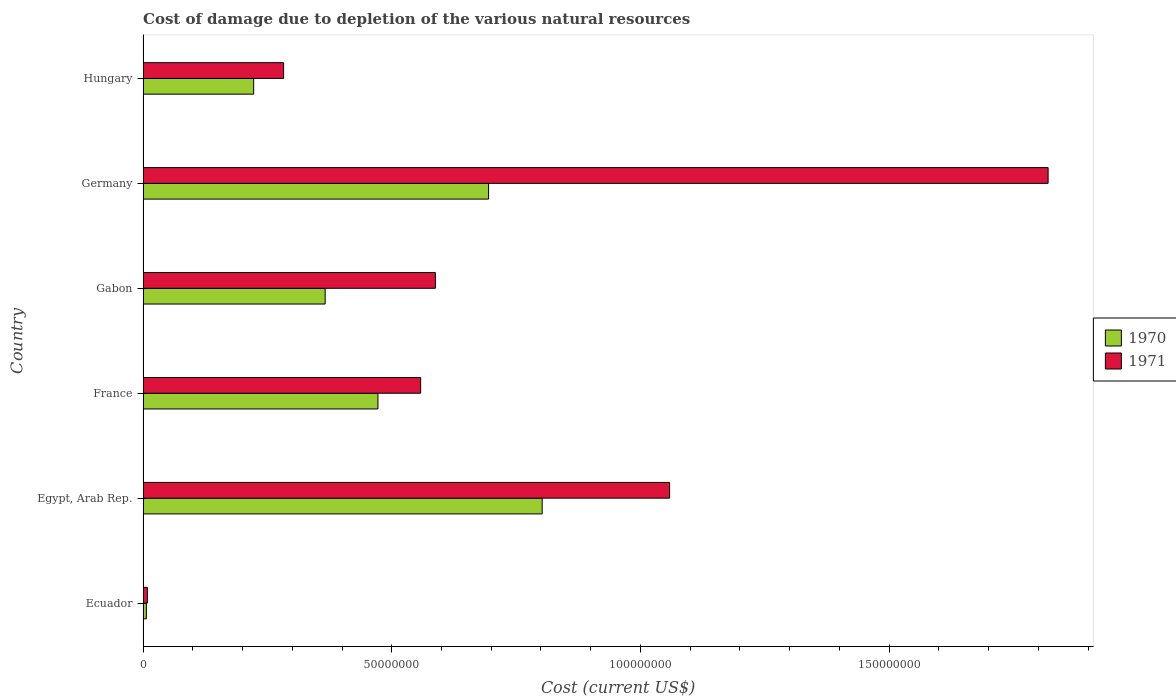How many different coloured bars are there?
Your response must be concise. 2. Are the number of bars per tick equal to the number of legend labels?
Your answer should be compact. Yes. Are the number of bars on each tick of the Y-axis equal?
Make the answer very short. Yes. What is the label of the 3rd group of bars from the top?
Make the answer very short. Gabon. What is the cost of damage caused due to the depletion of various natural resources in 1971 in Ecuador?
Offer a terse response. 8.71e+05. Across all countries, what is the maximum cost of damage caused due to the depletion of various natural resources in 1971?
Offer a very short reply. 1.82e+08. Across all countries, what is the minimum cost of damage caused due to the depletion of various natural resources in 1970?
Give a very brief answer. 6.65e+05. In which country was the cost of damage caused due to the depletion of various natural resources in 1970 maximum?
Ensure brevity in your answer.  Egypt, Arab Rep. In which country was the cost of damage caused due to the depletion of various natural resources in 1971 minimum?
Ensure brevity in your answer.  Ecuador. What is the total cost of damage caused due to the depletion of various natural resources in 1970 in the graph?
Keep it short and to the point. 2.56e+08. What is the difference between the cost of damage caused due to the depletion of various natural resources in 1971 in Gabon and that in Germany?
Ensure brevity in your answer.  -1.23e+08. What is the difference between the cost of damage caused due to the depletion of various natural resources in 1970 in Germany and the cost of damage caused due to the depletion of various natural resources in 1971 in France?
Provide a succinct answer. 1.37e+07. What is the average cost of damage caused due to the depletion of various natural resources in 1971 per country?
Provide a short and direct response. 7.19e+07. What is the difference between the cost of damage caused due to the depletion of various natural resources in 1971 and cost of damage caused due to the depletion of various natural resources in 1970 in Hungary?
Provide a short and direct response. 6.02e+06. In how many countries, is the cost of damage caused due to the depletion of various natural resources in 1970 greater than 180000000 US$?
Your answer should be very brief. 0. What is the ratio of the cost of damage caused due to the depletion of various natural resources in 1970 in France to that in Gabon?
Keep it short and to the point. 1.29. Is the cost of damage caused due to the depletion of various natural resources in 1971 in Egypt, Arab Rep. less than that in Gabon?
Ensure brevity in your answer.  No. Is the difference between the cost of damage caused due to the depletion of various natural resources in 1971 in France and Gabon greater than the difference between the cost of damage caused due to the depletion of various natural resources in 1970 in France and Gabon?
Provide a succinct answer. No. What is the difference between the highest and the second highest cost of damage caused due to the depletion of various natural resources in 1970?
Offer a terse response. 1.08e+07. What is the difference between the highest and the lowest cost of damage caused due to the depletion of various natural resources in 1971?
Give a very brief answer. 1.81e+08. Is the sum of the cost of damage caused due to the depletion of various natural resources in 1970 in Gabon and Germany greater than the maximum cost of damage caused due to the depletion of various natural resources in 1971 across all countries?
Offer a very short reply. No. What does the 2nd bar from the top in Ecuador represents?
Give a very brief answer. 1970. What does the 2nd bar from the bottom in Hungary represents?
Keep it short and to the point. 1971. Are all the bars in the graph horizontal?
Keep it short and to the point. Yes. How many countries are there in the graph?
Ensure brevity in your answer.  6. How are the legend labels stacked?
Make the answer very short. Vertical. What is the title of the graph?
Offer a terse response. Cost of damage due to depletion of the various natural resources. Does "1994" appear as one of the legend labels in the graph?
Your answer should be very brief. No. What is the label or title of the X-axis?
Provide a succinct answer. Cost (current US$). What is the label or title of the Y-axis?
Offer a very short reply. Country. What is the Cost (current US$) of 1970 in Ecuador?
Provide a succinct answer. 6.65e+05. What is the Cost (current US$) of 1971 in Ecuador?
Give a very brief answer. 8.71e+05. What is the Cost (current US$) of 1970 in Egypt, Arab Rep.?
Offer a very short reply. 8.02e+07. What is the Cost (current US$) in 1971 in Egypt, Arab Rep.?
Give a very brief answer. 1.06e+08. What is the Cost (current US$) in 1970 in France?
Give a very brief answer. 4.72e+07. What is the Cost (current US$) of 1971 in France?
Give a very brief answer. 5.58e+07. What is the Cost (current US$) in 1970 in Gabon?
Offer a very short reply. 3.66e+07. What is the Cost (current US$) of 1971 in Gabon?
Provide a succinct answer. 5.88e+07. What is the Cost (current US$) of 1970 in Germany?
Your answer should be very brief. 6.95e+07. What is the Cost (current US$) of 1971 in Germany?
Make the answer very short. 1.82e+08. What is the Cost (current US$) in 1970 in Hungary?
Your response must be concise. 2.22e+07. What is the Cost (current US$) of 1971 in Hungary?
Your response must be concise. 2.83e+07. Across all countries, what is the maximum Cost (current US$) of 1970?
Keep it short and to the point. 8.02e+07. Across all countries, what is the maximum Cost (current US$) in 1971?
Offer a terse response. 1.82e+08. Across all countries, what is the minimum Cost (current US$) of 1970?
Your answer should be very brief. 6.65e+05. Across all countries, what is the minimum Cost (current US$) of 1971?
Offer a very short reply. 8.71e+05. What is the total Cost (current US$) of 1970 in the graph?
Keep it short and to the point. 2.56e+08. What is the total Cost (current US$) of 1971 in the graph?
Provide a short and direct response. 4.32e+08. What is the difference between the Cost (current US$) of 1970 in Ecuador and that in Egypt, Arab Rep.?
Your answer should be very brief. -7.96e+07. What is the difference between the Cost (current US$) in 1971 in Ecuador and that in Egypt, Arab Rep.?
Your answer should be very brief. -1.05e+08. What is the difference between the Cost (current US$) in 1970 in Ecuador and that in France?
Make the answer very short. -4.66e+07. What is the difference between the Cost (current US$) in 1971 in Ecuador and that in France?
Offer a very short reply. -5.49e+07. What is the difference between the Cost (current US$) in 1970 in Ecuador and that in Gabon?
Provide a short and direct response. -3.59e+07. What is the difference between the Cost (current US$) of 1971 in Ecuador and that in Gabon?
Provide a succinct answer. -5.79e+07. What is the difference between the Cost (current US$) of 1970 in Ecuador and that in Germany?
Give a very brief answer. -6.88e+07. What is the difference between the Cost (current US$) in 1971 in Ecuador and that in Germany?
Keep it short and to the point. -1.81e+08. What is the difference between the Cost (current US$) of 1970 in Ecuador and that in Hungary?
Your response must be concise. -2.16e+07. What is the difference between the Cost (current US$) of 1971 in Ecuador and that in Hungary?
Give a very brief answer. -2.74e+07. What is the difference between the Cost (current US$) of 1970 in Egypt, Arab Rep. and that in France?
Ensure brevity in your answer.  3.30e+07. What is the difference between the Cost (current US$) in 1971 in Egypt, Arab Rep. and that in France?
Provide a short and direct response. 5.01e+07. What is the difference between the Cost (current US$) in 1970 in Egypt, Arab Rep. and that in Gabon?
Offer a terse response. 4.36e+07. What is the difference between the Cost (current US$) in 1971 in Egypt, Arab Rep. and that in Gabon?
Your response must be concise. 4.71e+07. What is the difference between the Cost (current US$) in 1970 in Egypt, Arab Rep. and that in Germany?
Your answer should be compact. 1.08e+07. What is the difference between the Cost (current US$) of 1971 in Egypt, Arab Rep. and that in Germany?
Offer a very short reply. -7.61e+07. What is the difference between the Cost (current US$) of 1970 in Egypt, Arab Rep. and that in Hungary?
Keep it short and to the point. 5.80e+07. What is the difference between the Cost (current US$) in 1971 in Egypt, Arab Rep. and that in Hungary?
Your answer should be compact. 7.76e+07. What is the difference between the Cost (current US$) in 1970 in France and that in Gabon?
Offer a terse response. 1.06e+07. What is the difference between the Cost (current US$) of 1971 in France and that in Gabon?
Offer a terse response. -2.96e+06. What is the difference between the Cost (current US$) of 1970 in France and that in Germany?
Your response must be concise. -2.22e+07. What is the difference between the Cost (current US$) in 1971 in France and that in Germany?
Your answer should be very brief. -1.26e+08. What is the difference between the Cost (current US$) in 1970 in France and that in Hungary?
Make the answer very short. 2.50e+07. What is the difference between the Cost (current US$) of 1971 in France and that in Hungary?
Provide a short and direct response. 2.76e+07. What is the difference between the Cost (current US$) in 1970 in Gabon and that in Germany?
Your answer should be very brief. -3.29e+07. What is the difference between the Cost (current US$) of 1971 in Gabon and that in Germany?
Make the answer very short. -1.23e+08. What is the difference between the Cost (current US$) in 1970 in Gabon and that in Hungary?
Provide a succinct answer. 1.44e+07. What is the difference between the Cost (current US$) of 1971 in Gabon and that in Hungary?
Offer a terse response. 3.05e+07. What is the difference between the Cost (current US$) of 1970 in Germany and that in Hungary?
Keep it short and to the point. 4.72e+07. What is the difference between the Cost (current US$) of 1971 in Germany and that in Hungary?
Keep it short and to the point. 1.54e+08. What is the difference between the Cost (current US$) in 1970 in Ecuador and the Cost (current US$) in 1971 in Egypt, Arab Rep.?
Your response must be concise. -1.05e+08. What is the difference between the Cost (current US$) of 1970 in Ecuador and the Cost (current US$) of 1971 in France?
Offer a terse response. -5.52e+07. What is the difference between the Cost (current US$) in 1970 in Ecuador and the Cost (current US$) in 1971 in Gabon?
Offer a very short reply. -5.81e+07. What is the difference between the Cost (current US$) of 1970 in Ecuador and the Cost (current US$) of 1971 in Germany?
Provide a short and direct response. -1.81e+08. What is the difference between the Cost (current US$) of 1970 in Ecuador and the Cost (current US$) of 1971 in Hungary?
Ensure brevity in your answer.  -2.76e+07. What is the difference between the Cost (current US$) of 1970 in Egypt, Arab Rep. and the Cost (current US$) of 1971 in France?
Keep it short and to the point. 2.44e+07. What is the difference between the Cost (current US$) of 1970 in Egypt, Arab Rep. and the Cost (current US$) of 1971 in Gabon?
Keep it short and to the point. 2.15e+07. What is the difference between the Cost (current US$) of 1970 in Egypt, Arab Rep. and the Cost (current US$) of 1971 in Germany?
Offer a terse response. -1.02e+08. What is the difference between the Cost (current US$) of 1970 in Egypt, Arab Rep. and the Cost (current US$) of 1971 in Hungary?
Provide a short and direct response. 5.20e+07. What is the difference between the Cost (current US$) of 1970 in France and the Cost (current US$) of 1971 in Gabon?
Give a very brief answer. -1.15e+07. What is the difference between the Cost (current US$) in 1970 in France and the Cost (current US$) in 1971 in Germany?
Provide a succinct answer. -1.35e+08. What is the difference between the Cost (current US$) in 1970 in France and the Cost (current US$) in 1971 in Hungary?
Your answer should be very brief. 1.90e+07. What is the difference between the Cost (current US$) of 1970 in Gabon and the Cost (current US$) of 1971 in Germany?
Your response must be concise. -1.45e+08. What is the difference between the Cost (current US$) of 1970 in Gabon and the Cost (current US$) of 1971 in Hungary?
Your response must be concise. 8.35e+06. What is the difference between the Cost (current US$) of 1970 in Germany and the Cost (current US$) of 1971 in Hungary?
Offer a terse response. 4.12e+07. What is the average Cost (current US$) in 1970 per country?
Offer a very short reply. 4.27e+07. What is the average Cost (current US$) in 1971 per country?
Your response must be concise. 7.19e+07. What is the difference between the Cost (current US$) in 1970 and Cost (current US$) in 1971 in Ecuador?
Ensure brevity in your answer.  -2.07e+05. What is the difference between the Cost (current US$) in 1970 and Cost (current US$) in 1971 in Egypt, Arab Rep.?
Your answer should be compact. -2.56e+07. What is the difference between the Cost (current US$) of 1970 and Cost (current US$) of 1971 in France?
Your answer should be very brief. -8.59e+06. What is the difference between the Cost (current US$) in 1970 and Cost (current US$) in 1971 in Gabon?
Keep it short and to the point. -2.22e+07. What is the difference between the Cost (current US$) in 1970 and Cost (current US$) in 1971 in Germany?
Your response must be concise. -1.13e+08. What is the difference between the Cost (current US$) of 1970 and Cost (current US$) of 1971 in Hungary?
Your answer should be very brief. -6.02e+06. What is the ratio of the Cost (current US$) in 1970 in Ecuador to that in Egypt, Arab Rep.?
Provide a succinct answer. 0.01. What is the ratio of the Cost (current US$) of 1971 in Ecuador to that in Egypt, Arab Rep.?
Offer a very short reply. 0.01. What is the ratio of the Cost (current US$) of 1970 in Ecuador to that in France?
Ensure brevity in your answer.  0.01. What is the ratio of the Cost (current US$) of 1971 in Ecuador to that in France?
Keep it short and to the point. 0.02. What is the ratio of the Cost (current US$) in 1970 in Ecuador to that in Gabon?
Keep it short and to the point. 0.02. What is the ratio of the Cost (current US$) in 1971 in Ecuador to that in Gabon?
Your response must be concise. 0.01. What is the ratio of the Cost (current US$) of 1970 in Ecuador to that in Germany?
Give a very brief answer. 0.01. What is the ratio of the Cost (current US$) of 1971 in Ecuador to that in Germany?
Ensure brevity in your answer.  0. What is the ratio of the Cost (current US$) in 1970 in Ecuador to that in Hungary?
Provide a succinct answer. 0.03. What is the ratio of the Cost (current US$) of 1971 in Ecuador to that in Hungary?
Your answer should be compact. 0.03. What is the ratio of the Cost (current US$) of 1970 in Egypt, Arab Rep. to that in France?
Your answer should be very brief. 1.7. What is the ratio of the Cost (current US$) of 1971 in Egypt, Arab Rep. to that in France?
Your response must be concise. 1.9. What is the ratio of the Cost (current US$) in 1970 in Egypt, Arab Rep. to that in Gabon?
Your response must be concise. 2.19. What is the ratio of the Cost (current US$) of 1971 in Egypt, Arab Rep. to that in Gabon?
Keep it short and to the point. 1.8. What is the ratio of the Cost (current US$) in 1970 in Egypt, Arab Rep. to that in Germany?
Your answer should be very brief. 1.16. What is the ratio of the Cost (current US$) in 1971 in Egypt, Arab Rep. to that in Germany?
Provide a succinct answer. 0.58. What is the ratio of the Cost (current US$) of 1970 in Egypt, Arab Rep. to that in Hungary?
Ensure brevity in your answer.  3.61. What is the ratio of the Cost (current US$) of 1971 in Egypt, Arab Rep. to that in Hungary?
Offer a terse response. 3.75. What is the ratio of the Cost (current US$) in 1970 in France to that in Gabon?
Provide a short and direct response. 1.29. What is the ratio of the Cost (current US$) in 1971 in France to that in Gabon?
Give a very brief answer. 0.95. What is the ratio of the Cost (current US$) of 1970 in France to that in Germany?
Provide a succinct answer. 0.68. What is the ratio of the Cost (current US$) of 1971 in France to that in Germany?
Offer a terse response. 0.31. What is the ratio of the Cost (current US$) of 1970 in France to that in Hungary?
Provide a succinct answer. 2.12. What is the ratio of the Cost (current US$) in 1971 in France to that in Hungary?
Offer a terse response. 1.98. What is the ratio of the Cost (current US$) of 1970 in Gabon to that in Germany?
Provide a short and direct response. 0.53. What is the ratio of the Cost (current US$) in 1971 in Gabon to that in Germany?
Provide a succinct answer. 0.32. What is the ratio of the Cost (current US$) in 1970 in Gabon to that in Hungary?
Ensure brevity in your answer.  1.65. What is the ratio of the Cost (current US$) in 1971 in Gabon to that in Hungary?
Ensure brevity in your answer.  2.08. What is the ratio of the Cost (current US$) of 1970 in Germany to that in Hungary?
Provide a succinct answer. 3.12. What is the ratio of the Cost (current US$) in 1971 in Germany to that in Hungary?
Your response must be concise. 6.44. What is the difference between the highest and the second highest Cost (current US$) in 1970?
Offer a terse response. 1.08e+07. What is the difference between the highest and the second highest Cost (current US$) of 1971?
Your answer should be compact. 7.61e+07. What is the difference between the highest and the lowest Cost (current US$) of 1970?
Make the answer very short. 7.96e+07. What is the difference between the highest and the lowest Cost (current US$) in 1971?
Ensure brevity in your answer.  1.81e+08. 